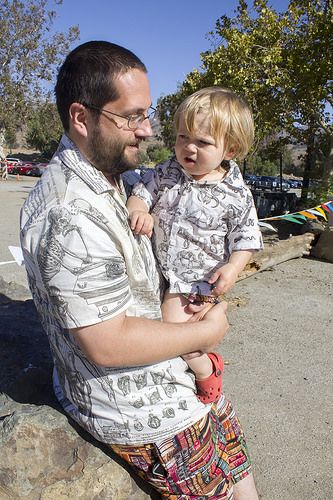<image>
Is the tree behind the child? Yes. From this viewpoint, the tree is positioned behind the child, with the child partially or fully occluding the tree. 